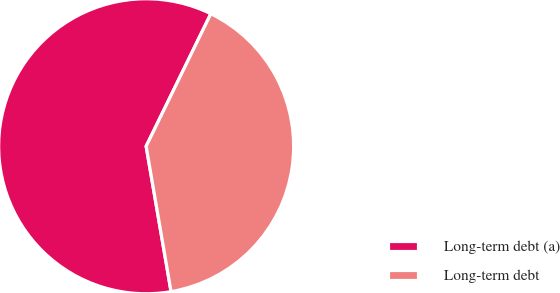<chart> <loc_0><loc_0><loc_500><loc_500><pie_chart><fcel>Long-term debt (a)<fcel>Long-term debt<nl><fcel>59.93%<fcel>40.07%<nl></chart> 